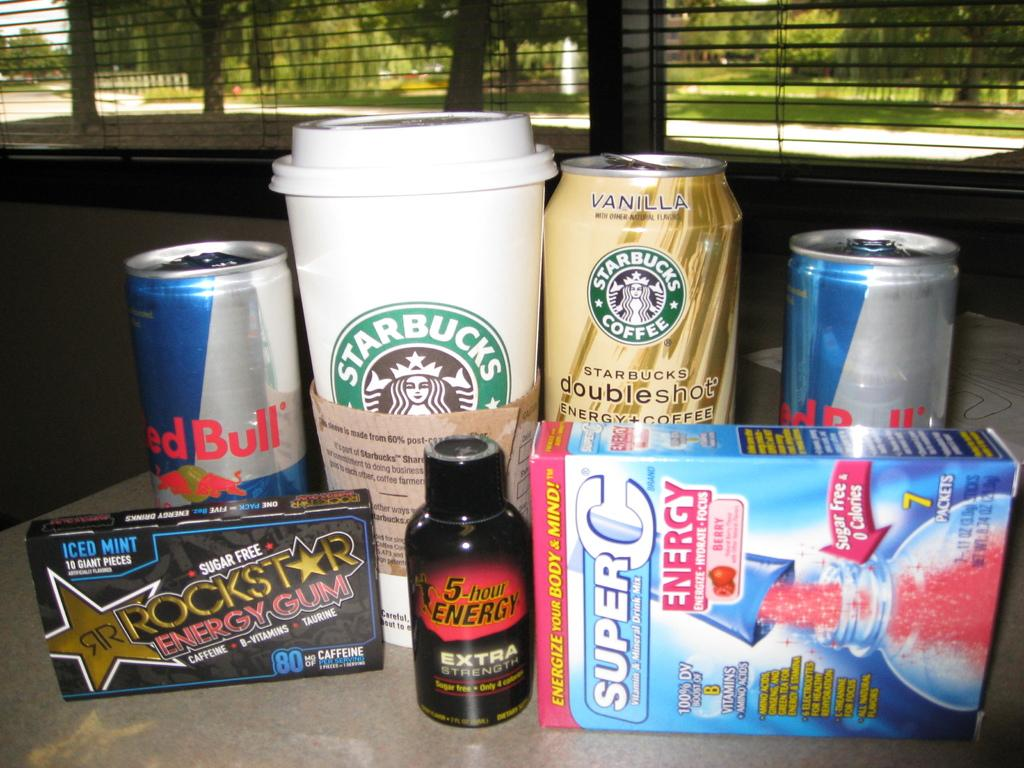<image>
Render a clear and concise summary of the photo. Starbucks cup and can, rockstar gum, super c energy, and red bull cans. 